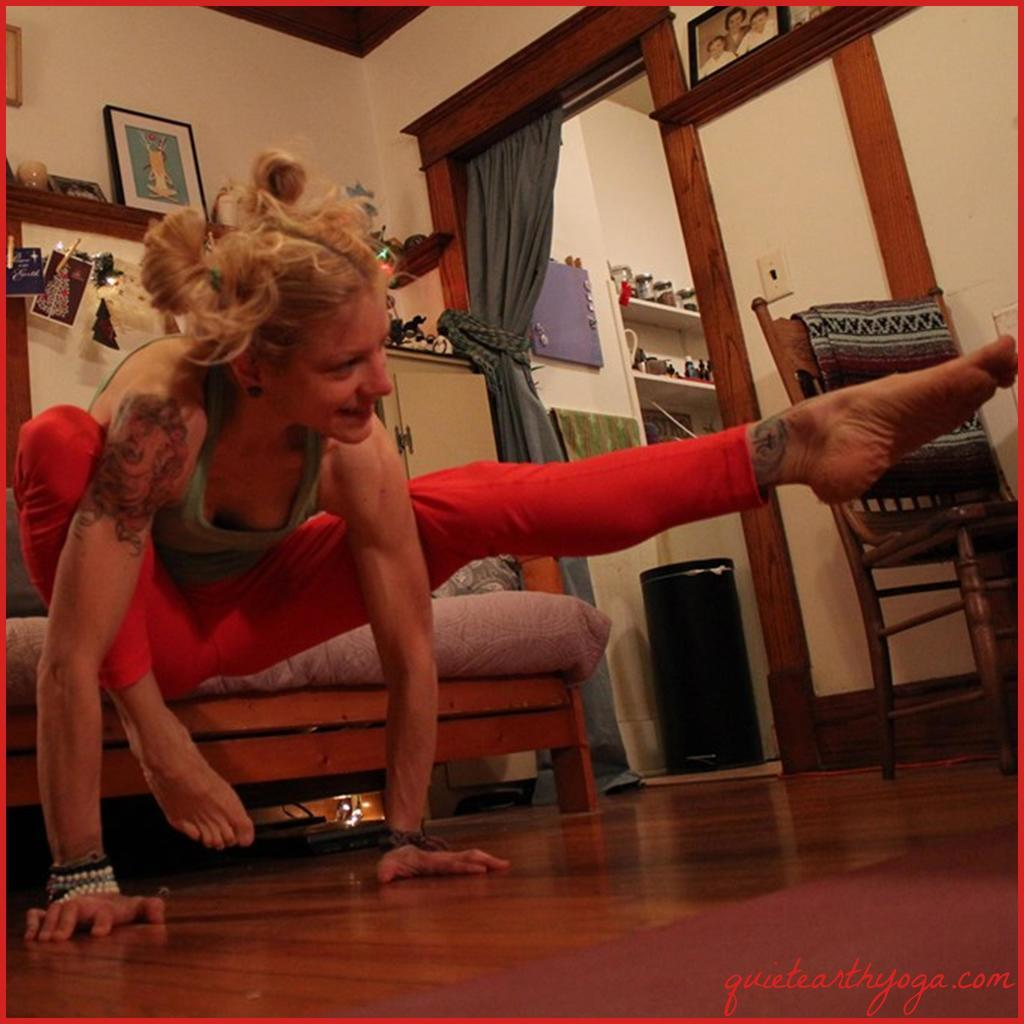Who is present in the image? There is a woman in the image. What type of furniture can be seen in the image? There is a chair and a sofa in the image. What is on the wall in the image? There is a photo on the wall in the image. What architectural feature is visible in the image? There is a door in the image. What type of vegetable is growing on the chair in the image? There are no vegetables present in the image, and the chair is not a place where vegetables would grow. 